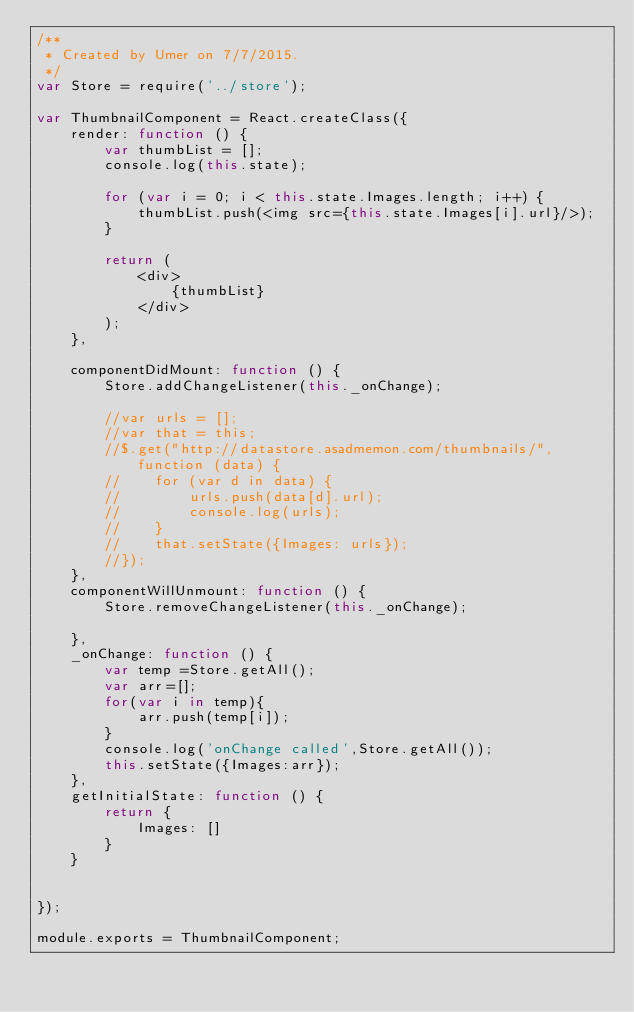<code> <loc_0><loc_0><loc_500><loc_500><_JavaScript_>/**
 * Created by Umer on 7/7/2015.
 */
var Store = require('../store');

var ThumbnailComponent = React.createClass({
    render: function () {
        var thumbList = [];
        console.log(this.state);

        for (var i = 0; i < this.state.Images.length; i++) {
            thumbList.push(<img src={this.state.Images[i].url}/>);
        }

        return (
            <div>
                {thumbList}
            </div>
        );
    },

    componentDidMount: function () {
        Store.addChangeListener(this._onChange);

        //var urls = [];
        //var that = this;
        //$.get("http://datastore.asadmemon.com/thumbnails/", function (data) {
        //    for (var d in data) {
        //        urls.push(data[d].url);
        //        console.log(urls);
        //    }
        //    that.setState({Images: urls});
        //});
    },
    componentWillUnmount: function () {
        Store.removeChangeListener(this._onChange);

    },
    _onChange: function () {
        var temp =Store.getAll();
        var arr=[];
        for(var i in temp){
            arr.push(temp[i]);
        }
        console.log('onChange called',Store.getAll());
        this.setState({Images:arr});
    },
    getInitialState: function () {
        return {
            Images: []
        }
    }


});

module.exports = ThumbnailComponent;
</code> 